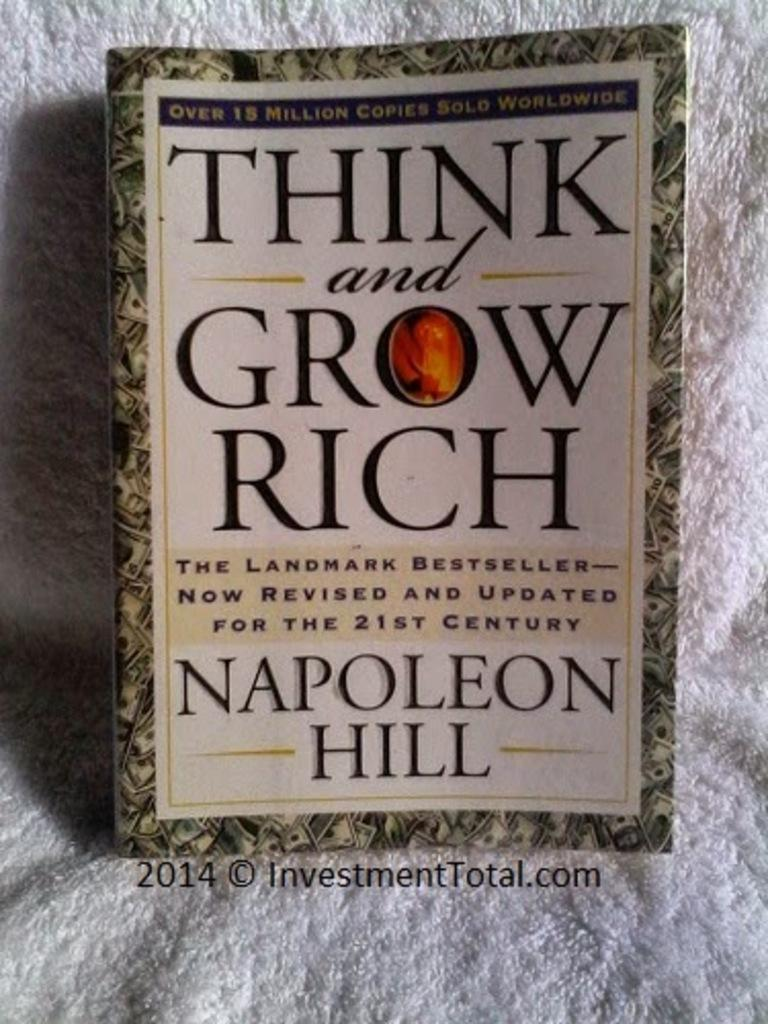<image>
Offer a succinct explanation of the picture presented. A book by Napoleon Hill has black lettering on it. 